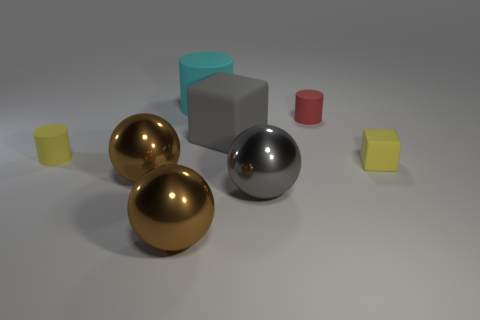Subtract all brown balls. How many were subtracted if there are1brown balls left? 1 Subtract all green spheres. Subtract all gray cubes. How many spheres are left? 3 Add 2 big matte cubes. How many objects exist? 10 Subtract all cylinders. How many objects are left? 5 Subtract 0 red blocks. How many objects are left? 8 Subtract all brown balls. Subtract all gray objects. How many objects are left? 4 Add 8 red things. How many red things are left? 9 Add 5 large things. How many large things exist? 10 